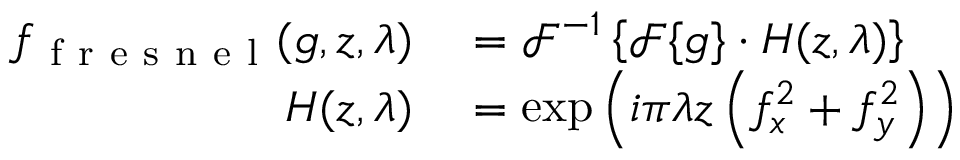<formula> <loc_0><loc_0><loc_500><loc_500>\begin{array} { r l } { f _ { f r e s n e l } ( g , z , \lambda ) } & = \mathcal { F } ^ { - 1 } \left \{ \mathcal { F } \{ g \} \cdot H ( z , \lambda ) \right \} } \\ { H ( z , \lambda ) } & = \exp \left ( i \pi \lambda z \left ( f _ { x } ^ { 2 } + f _ { y } ^ { 2 } \right ) \right ) } \end{array}</formula> 